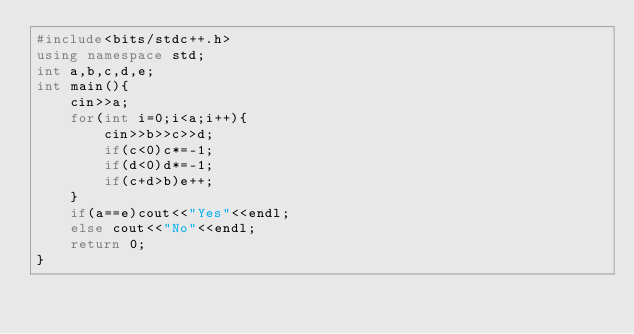Convert code to text. <code><loc_0><loc_0><loc_500><loc_500><_C++_>#include<bits/stdc++.h>
using namespace std;
int a,b,c,d,e;
int main(){
    cin>>a;
    for(int i=0;i<a;i++){
        cin>>b>>c>>d;
        if(c<0)c*=-1;
        if(d<0)d*=-1;
        if(c+d>b)e++;
    }
    if(a==e)cout<<"Yes"<<endl;
    else cout<<"No"<<endl;
    return 0;
}</code> 